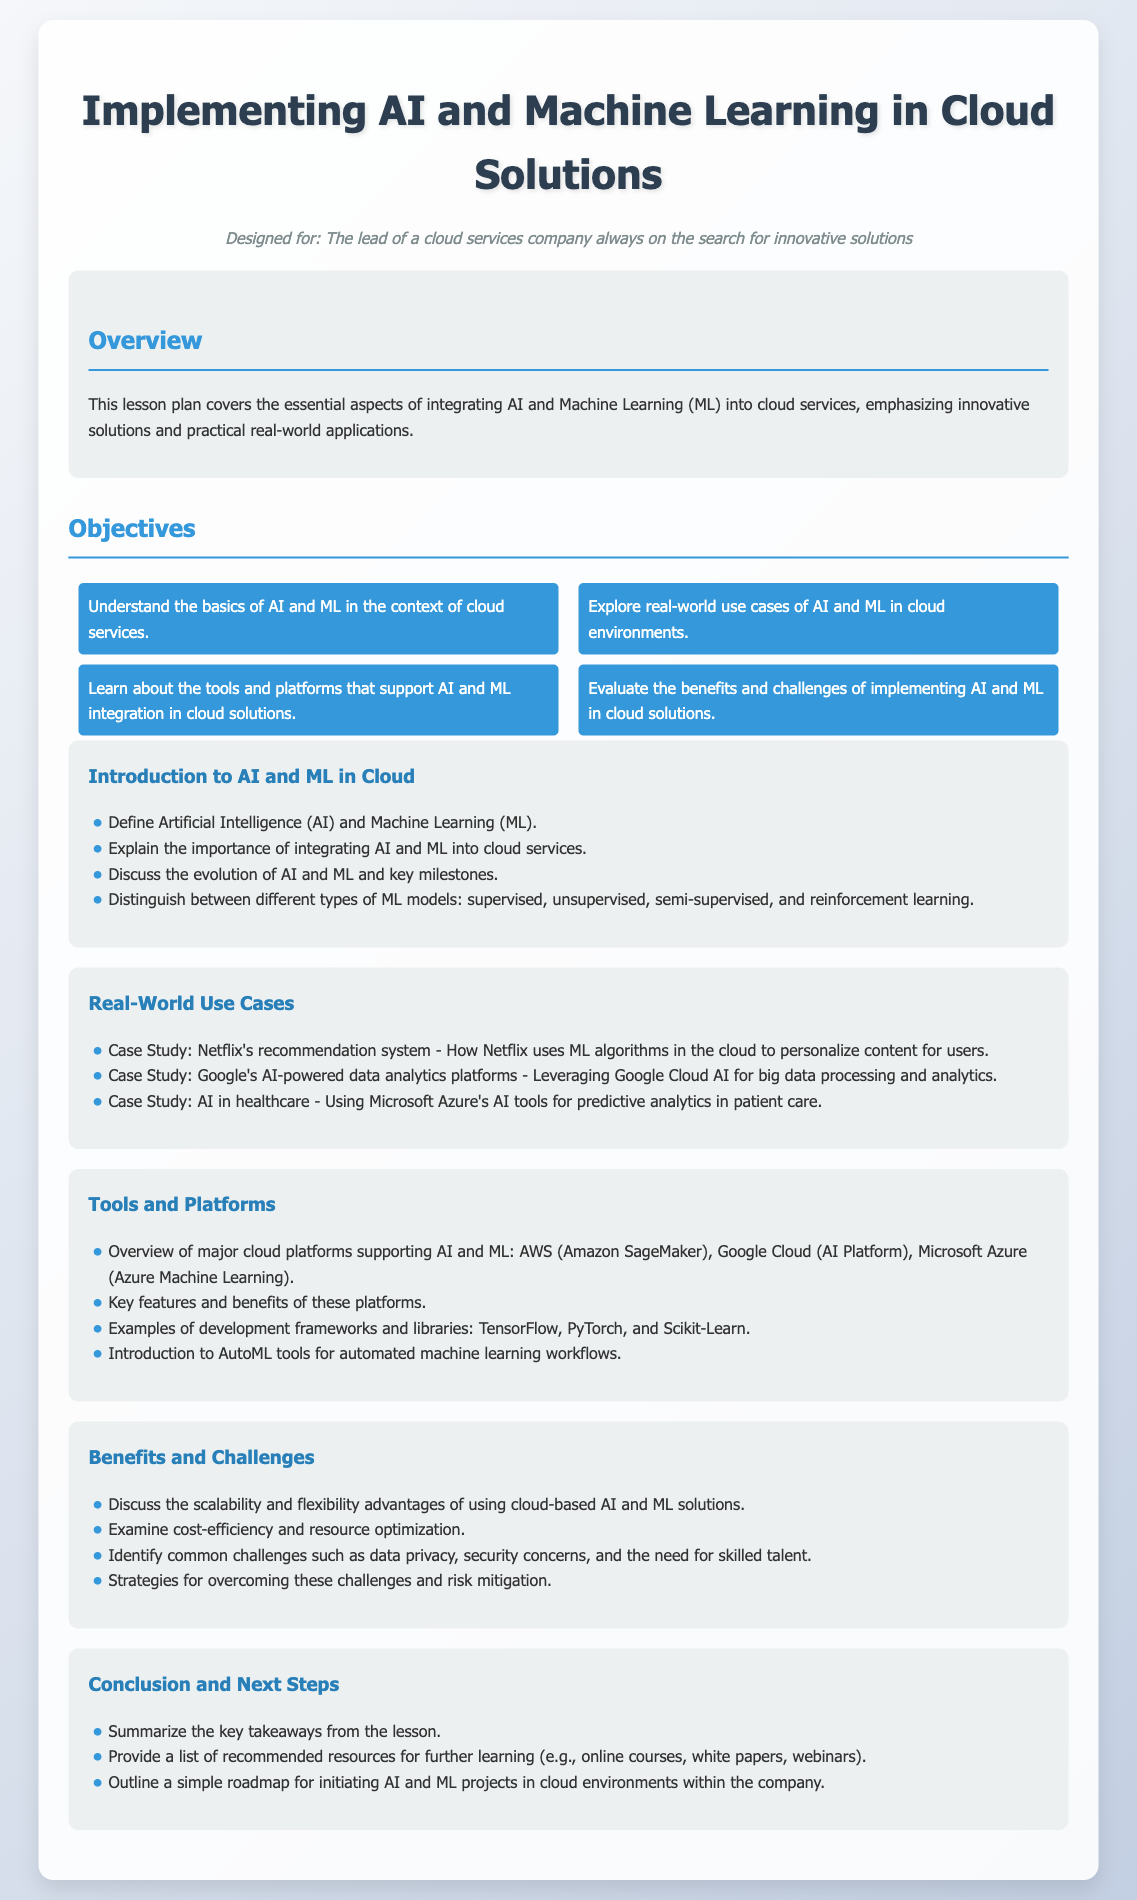What does the lesson plan focus on? The lesson plan focuses on the essential aspects of integrating AI and Machine Learning into cloud services.
Answer: integrating AI and Machine Learning into cloud services What are the key types of Machine Learning models mentioned? The document distinguishes between supervised, unsupervised, semi-supervised, and reinforcement learning models.
Answer: supervised, unsupervised, semi-supervised, reinforcement learning How many real-world use cases are explored in the document? There are three real-world use cases provided in the section.
Answer: three Which cloud platforms are mentioned for supporting AI and Machine Learning? The document mentions AWS, Google Cloud, and Microsoft Azure as major platforms.
Answer: AWS, Google Cloud, Microsoft Azure What is one challenge identified in implementing AI and ML in cloud solutions? One challenge discussed is data privacy.
Answer: data privacy What type of tools are introduced for automated processes in the document? The document introduces AutoML tools for automated machine learning workflows.
Answer: AutoML tools What is one benefit of using cloud-based AI and ML solutions? The document discusses scalability as a key benefit.
Answer: scalability How many objectives are listed in the lesson plan? The lesson plan lists four objectives for the lesson.
Answer: four What is the last section of the document titled? The last section of the document is titled "Conclusion and Next Steps."
Answer: Conclusion and Next Steps 